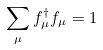<formula> <loc_0><loc_0><loc_500><loc_500>\sum _ { \mu } f ^ { \dagger } _ { \mu } f _ { \mu } = 1</formula> 